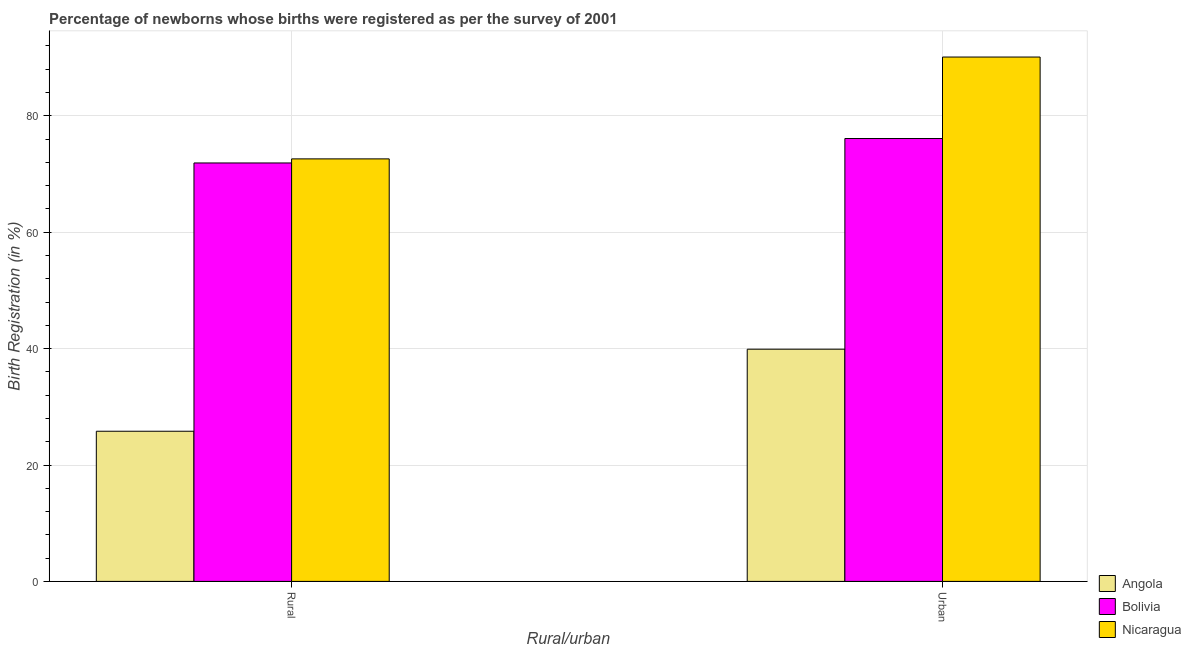How many groups of bars are there?
Give a very brief answer. 2. How many bars are there on the 1st tick from the right?
Give a very brief answer. 3. What is the label of the 2nd group of bars from the left?
Keep it short and to the point. Urban. What is the urban birth registration in Bolivia?
Keep it short and to the point. 76.1. Across all countries, what is the maximum urban birth registration?
Make the answer very short. 90.1. Across all countries, what is the minimum urban birth registration?
Provide a short and direct response. 39.9. In which country was the rural birth registration maximum?
Your answer should be compact. Nicaragua. In which country was the rural birth registration minimum?
Your response must be concise. Angola. What is the total rural birth registration in the graph?
Offer a terse response. 170.3. What is the difference between the rural birth registration in Nicaragua and that in Angola?
Your answer should be very brief. 46.8. What is the difference between the rural birth registration in Nicaragua and the urban birth registration in Angola?
Your answer should be compact. 32.7. What is the average rural birth registration per country?
Offer a terse response. 56.77. What is the difference between the urban birth registration and rural birth registration in Nicaragua?
Your answer should be very brief. 17.5. What is the ratio of the urban birth registration in Bolivia to that in Angola?
Provide a short and direct response. 1.91. What does the 3rd bar from the left in Rural represents?
Provide a short and direct response. Nicaragua. What does the 3rd bar from the right in Rural represents?
Your answer should be compact. Angola. How many bars are there?
Your response must be concise. 6. Are all the bars in the graph horizontal?
Provide a succinct answer. No. Does the graph contain any zero values?
Offer a very short reply. No. Does the graph contain grids?
Make the answer very short. Yes. How are the legend labels stacked?
Ensure brevity in your answer.  Vertical. What is the title of the graph?
Keep it short and to the point. Percentage of newborns whose births were registered as per the survey of 2001. What is the label or title of the X-axis?
Your answer should be compact. Rural/urban. What is the label or title of the Y-axis?
Make the answer very short. Birth Registration (in %). What is the Birth Registration (in %) of Angola in Rural?
Your answer should be compact. 25.8. What is the Birth Registration (in %) of Bolivia in Rural?
Give a very brief answer. 71.9. What is the Birth Registration (in %) in Nicaragua in Rural?
Make the answer very short. 72.6. What is the Birth Registration (in %) in Angola in Urban?
Offer a very short reply. 39.9. What is the Birth Registration (in %) of Bolivia in Urban?
Make the answer very short. 76.1. What is the Birth Registration (in %) in Nicaragua in Urban?
Keep it short and to the point. 90.1. Across all Rural/urban, what is the maximum Birth Registration (in %) in Angola?
Give a very brief answer. 39.9. Across all Rural/urban, what is the maximum Birth Registration (in %) in Bolivia?
Make the answer very short. 76.1. Across all Rural/urban, what is the maximum Birth Registration (in %) in Nicaragua?
Give a very brief answer. 90.1. Across all Rural/urban, what is the minimum Birth Registration (in %) of Angola?
Provide a short and direct response. 25.8. Across all Rural/urban, what is the minimum Birth Registration (in %) in Bolivia?
Give a very brief answer. 71.9. Across all Rural/urban, what is the minimum Birth Registration (in %) of Nicaragua?
Your answer should be very brief. 72.6. What is the total Birth Registration (in %) in Angola in the graph?
Keep it short and to the point. 65.7. What is the total Birth Registration (in %) in Bolivia in the graph?
Your answer should be very brief. 148. What is the total Birth Registration (in %) of Nicaragua in the graph?
Keep it short and to the point. 162.7. What is the difference between the Birth Registration (in %) of Angola in Rural and that in Urban?
Keep it short and to the point. -14.1. What is the difference between the Birth Registration (in %) of Nicaragua in Rural and that in Urban?
Provide a succinct answer. -17.5. What is the difference between the Birth Registration (in %) in Angola in Rural and the Birth Registration (in %) in Bolivia in Urban?
Your response must be concise. -50.3. What is the difference between the Birth Registration (in %) in Angola in Rural and the Birth Registration (in %) in Nicaragua in Urban?
Make the answer very short. -64.3. What is the difference between the Birth Registration (in %) of Bolivia in Rural and the Birth Registration (in %) of Nicaragua in Urban?
Provide a succinct answer. -18.2. What is the average Birth Registration (in %) in Angola per Rural/urban?
Your answer should be compact. 32.85. What is the average Birth Registration (in %) of Bolivia per Rural/urban?
Provide a succinct answer. 74. What is the average Birth Registration (in %) of Nicaragua per Rural/urban?
Your answer should be very brief. 81.35. What is the difference between the Birth Registration (in %) of Angola and Birth Registration (in %) of Bolivia in Rural?
Your answer should be compact. -46.1. What is the difference between the Birth Registration (in %) of Angola and Birth Registration (in %) of Nicaragua in Rural?
Ensure brevity in your answer.  -46.8. What is the difference between the Birth Registration (in %) of Angola and Birth Registration (in %) of Bolivia in Urban?
Provide a short and direct response. -36.2. What is the difference between the Birth Registration (in %) of Angola and Birth Registration (in %) of Nicaragua in Urban?
Offer a very short reply. -50.2. What is the ratio of the Birth Registration (in %) in Angola in Rural to that in Urban?
Provide a succinct answer. 0.65. What is the ratio of the Birth Registration (in %) of Bolivia in Rural to that in Urban?
Offer a terse response. 0.94. What is the ratio of the Birth Registration (in %) in Nicaragua in Rural to that in Urban?
Ensure brevity in your answer.  0.81. What is the difference between the highest and the second highest Birth Registration (in %) in Angola?
Your answer should be very brief. 14.1. What is the difference between the highest and the second highest Birth Registration (in %) in Nicaragua?
Your response must be concise. 17.5. What is the difference between the highest and the lowest Birth Registration (in %) of Angola?
Make the answer very short. 14.1. What is the difference between the highest and the lowest Birth Registration (in %) in Nicaragua?
Your answer should be compact. 17.5. 